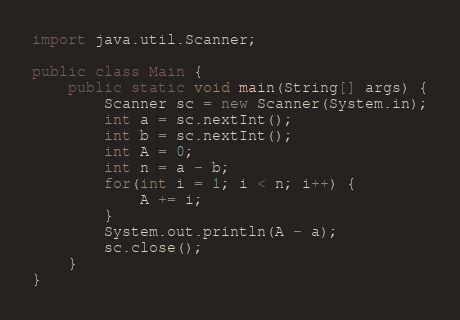<code> <loc_0><loc_0><loc_500><loc_500><_Java_>import java.util.Scanner;

public class Main {
	public static void main(String[] args) {
		Scanner sc = new Scanner(System.in);
		int a = sc.nextInt();
		int b = sc.nextInt();
		int A = 0;
		int n = a - b;
		for(int i = 1; i < n; i++) {
			A += i;
		}
		System.out.println(A - a);
		sc.close();
	}
}
</code> 